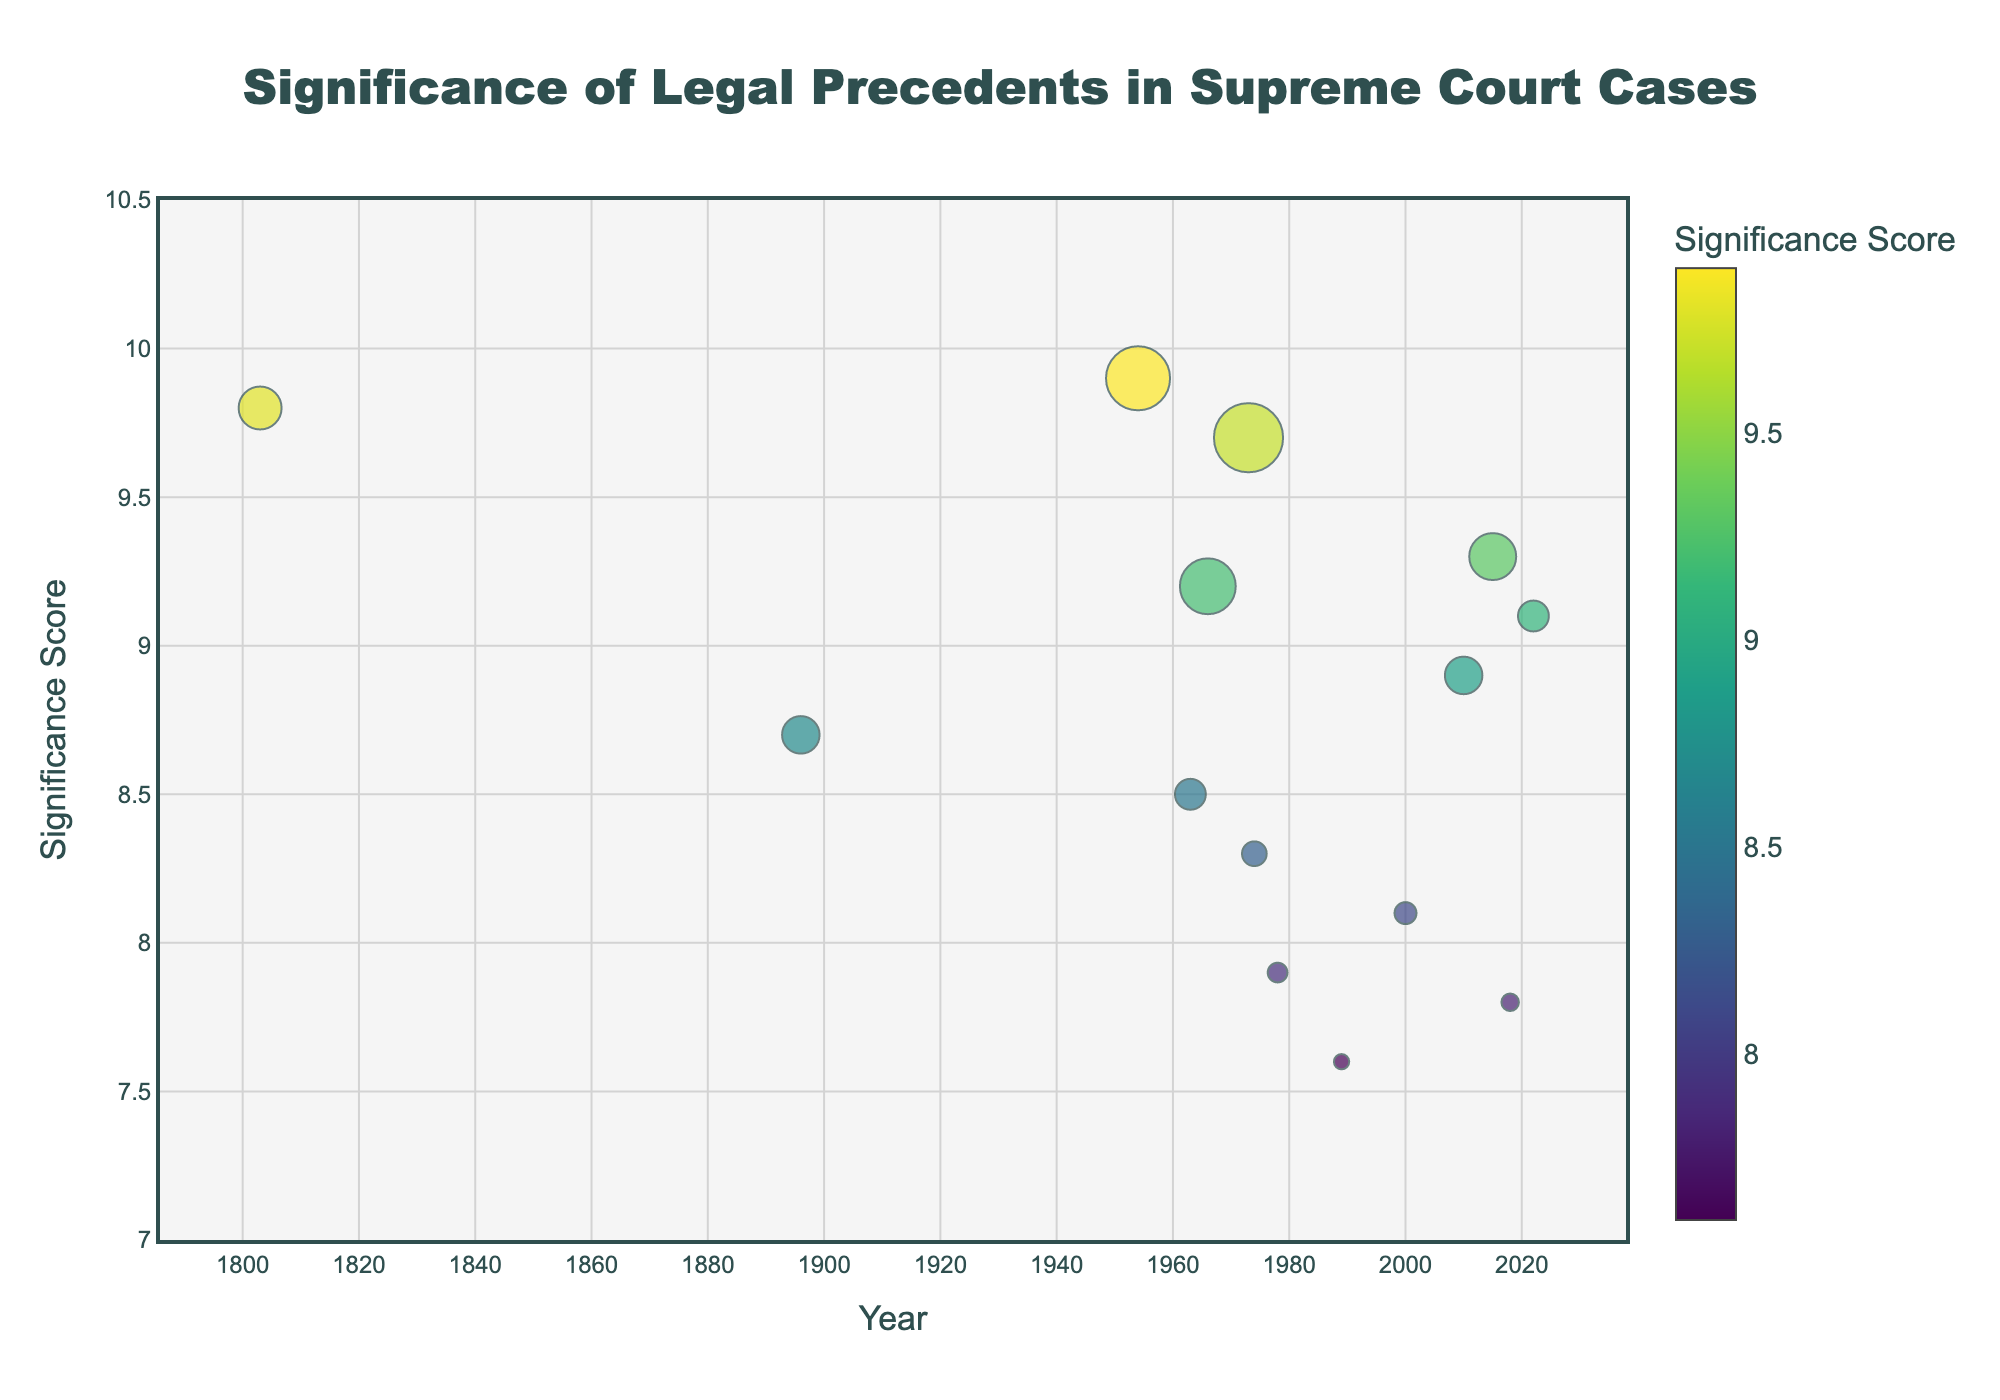How many legal precedents are displayed in the plot? Count each data point on the plot. Each point represents a legal precedent. In this case, there are 14 legal precedents shown.
Answer: 14 Which precedent has the highest significance score, and what is its value? Check the significance score axis and identify the data point that reaches the highest value. The title of this precedent is displayed upon hovering. Brown v. Board of Education has the highest significance score of 9.9.
Answer: Brown v. Board of Education, 9.9 What is the significance score of the most frequently cited precedent? Identify the data point with the largest marker size, then check its corresponding significance score. Roe v. Wade has the largest marker size and a significance score of 9.7.
Answer: 9.7 How many precedents have a significance score greater than 9.0? Identify the points above the significance score of 9.0 on the y-axis, count these points. There are five such precedents.
Answer: 5 What is the difference in significance scores between Marbury v. Madison and Roe v. Wade? Locate these two precedents in the plot and note their significance scores. Subtract Marbury v. Madison's significance score from Roe v. Wade's significance score (9.7 - 9.8).
Answer: -0.1 Which precedent cited in the 21st century has the highest significance score? Identify the data points from 2001 onwards, then compare their significance scores. Obergefell v. Hodges, cited in 2015, has the highest score at 9.3.
Answer: Obergefell v. Hodges Between Marbury v. Madison and Plessy v. Ferguson, which has fewer citations? Locate these two precedents on the plot and compare the sizes of their markers (which represent citation counts). Plessy v. Ferguson has fewer citations (1876 vs. 2145).
Answer: Plessy v. Ferguson Which precedent has a midpoint significance score between Miranda v. Arizona, Marbury v. Madison, and Roe v. Wade? Identify the significance scores for Miranda v. Arizona (9.2), Marbury v. Madison (9.8), and Roe v. Wade (9.7). Calculate the midpoint (average) of these scores ((9.2 + 9.8 + 9.7)/3 = 9.5666). None of the points fall exactly at this value; Roe v. Wade is closest with 9.7.
Answer: Roe v. Wade In which decade did the most significant Supreme Court cases occur? Examine the distribution of data points and select the decade with the highest grouping of high significance scores. The 1950s, 1960s, and 1970s have notable cases; however, the 1970s appear most prominent with cases like Roe v. Wade and United States v. Nixon.
Answer: 1970s 